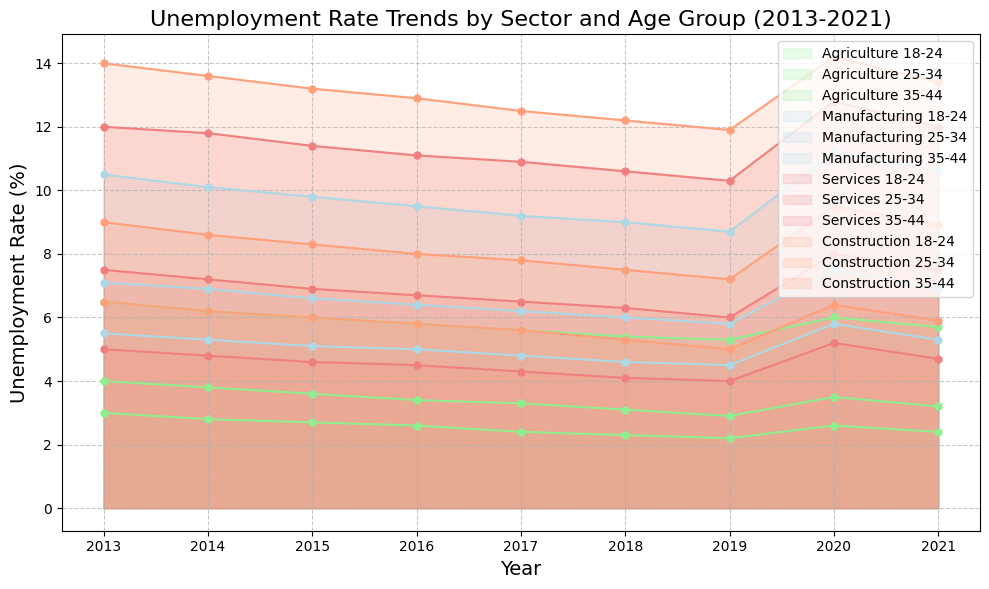What's the highest unemployment rate recorded in the Construction sector for the 18-24 age group? Identify the Construction sector and the 18-24 age group. The highest recorded unemployment rate for this segment is in the year 2013 at 14%.
Answer: 14% Which sector and age group experienced a significant increase in unemployment rate in 2020 compared to 2019? Analyze the trend lines and areas visually indicating changes from 2019 to 2020. The Services sector for the 18-24 age group shows a considerable increase from 10.3% in 2019 to 12.8% in 2020.
Answer: Services 18-24 How did the unemployment rate for Agriculture sector (18-24) change over the decade? Follow the trend line for the Agriculture sector and the 18-24 age group from 2013 (6.5%) to 2021 (5.7%). The rate generally declines over the decade, with a spike in 2020.
Answer: Decreased overall Compare the unemployment rates for Manufacturing sector, 25-34 age group in 2018 and 2020. What do you observe? Observe the plot points and areas for the Manufacturing sector and 25-34 age group at the years 2018 (6.0%) and 2020 (7.5%). The rate increases by 1.5% in 2020 compared to 2018.
Answer: Increased in 2020 What is the average unemployment rate for the Services sector, 35-44 age group from 2013 to 2021? Calculate the average of the unemployment rates for this segment over the specified years: (5.0 + 4.8 + 4.6 + 4.5 + 4.3 + 4.1 + 4.0 + 5.2 + 4.7) / 9 = 4.58%.
Answer: 4.58% Between the years 2019 and 2020, which sector for the 25-34 age group saw the largest increase in unemployment rate? Focus on the trend changes from 2019 to 2020 for the 25-34 age group in every sector. Construction had an increase from 7.2% to 9.5%, the largest among the sectors.
Answer: Construction Which sector consistently shows the highest unemployment rates across all age groups? Observe the height of graphical areas; the sector consistently showing higher peaks is the Services sector.
Answer: Services Which sector and age group saw the most decrease in unemployment rate from 2013 to 2019? Compare the beginning and end points; Agriculture sector for the 35-44 age group decreases from 3.0% to 2.2%, a decrease of 0.8%.
Answer: Agriculture 35-44 Compare the unemployment rates for the 18-24 age group in the Agriculture and Manufacturing sectors in 2021. Which is higher? Observe the plot points in 2021 for both sectors in the 18-24 age group: Agriculture at 5.7% vs. Manufacturing at 10.6%. Manufacturing is higher.
Answer: Manufacturing What visual pattern do you observe in the Services sector's employment rate for the 18-24 age group over the years? The area for Services sector in 18-24 age group shows a fluctuating pattern with peaks in 2013 and 2020 and a general decline from 2014 to 2019.
Answer: Fluctuating with peaks 